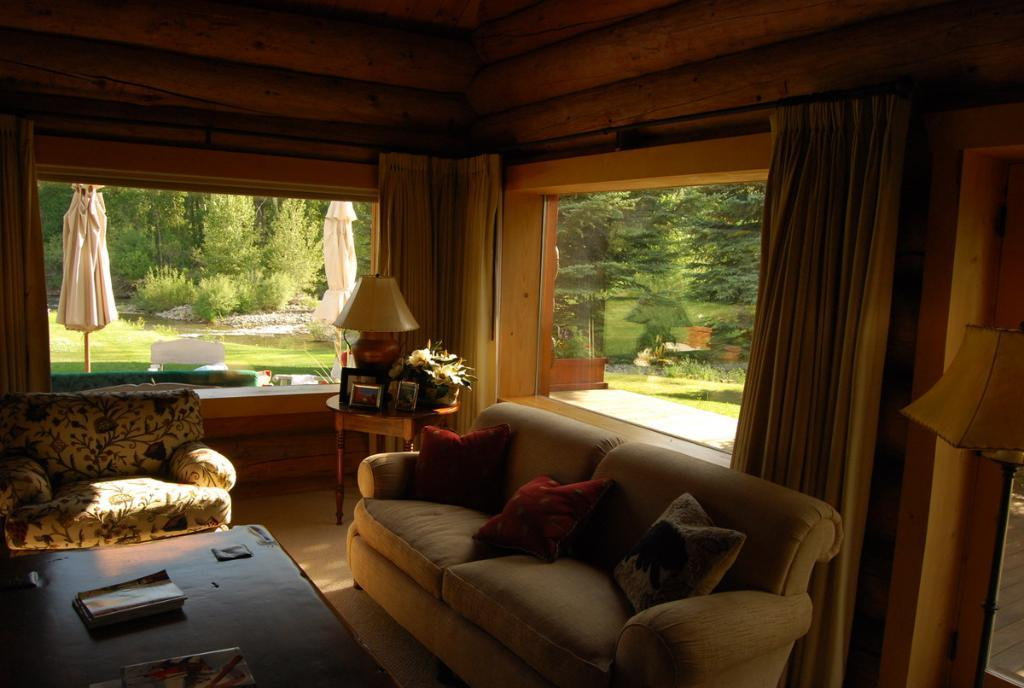What type of furniture is present in the image? There is a couch with pillows and a sofa in the image. What is the source of light in the room? There is a lamp in the image. Is there any greenery visible in the image? Yes, there is a plant in the image, and trees and grass are visible through the window. What can be seen outside the window? Trees, grass, and a small water body are visible through the window. What type of invention is being demonstrated in the image? There is no invention being demonstrated in the image; it features a couch, a sofa, a lamp, a plant, and a window with a view of the outdoors. Is there any smoke visible in the image? No, there is no smoke visible in the image. 